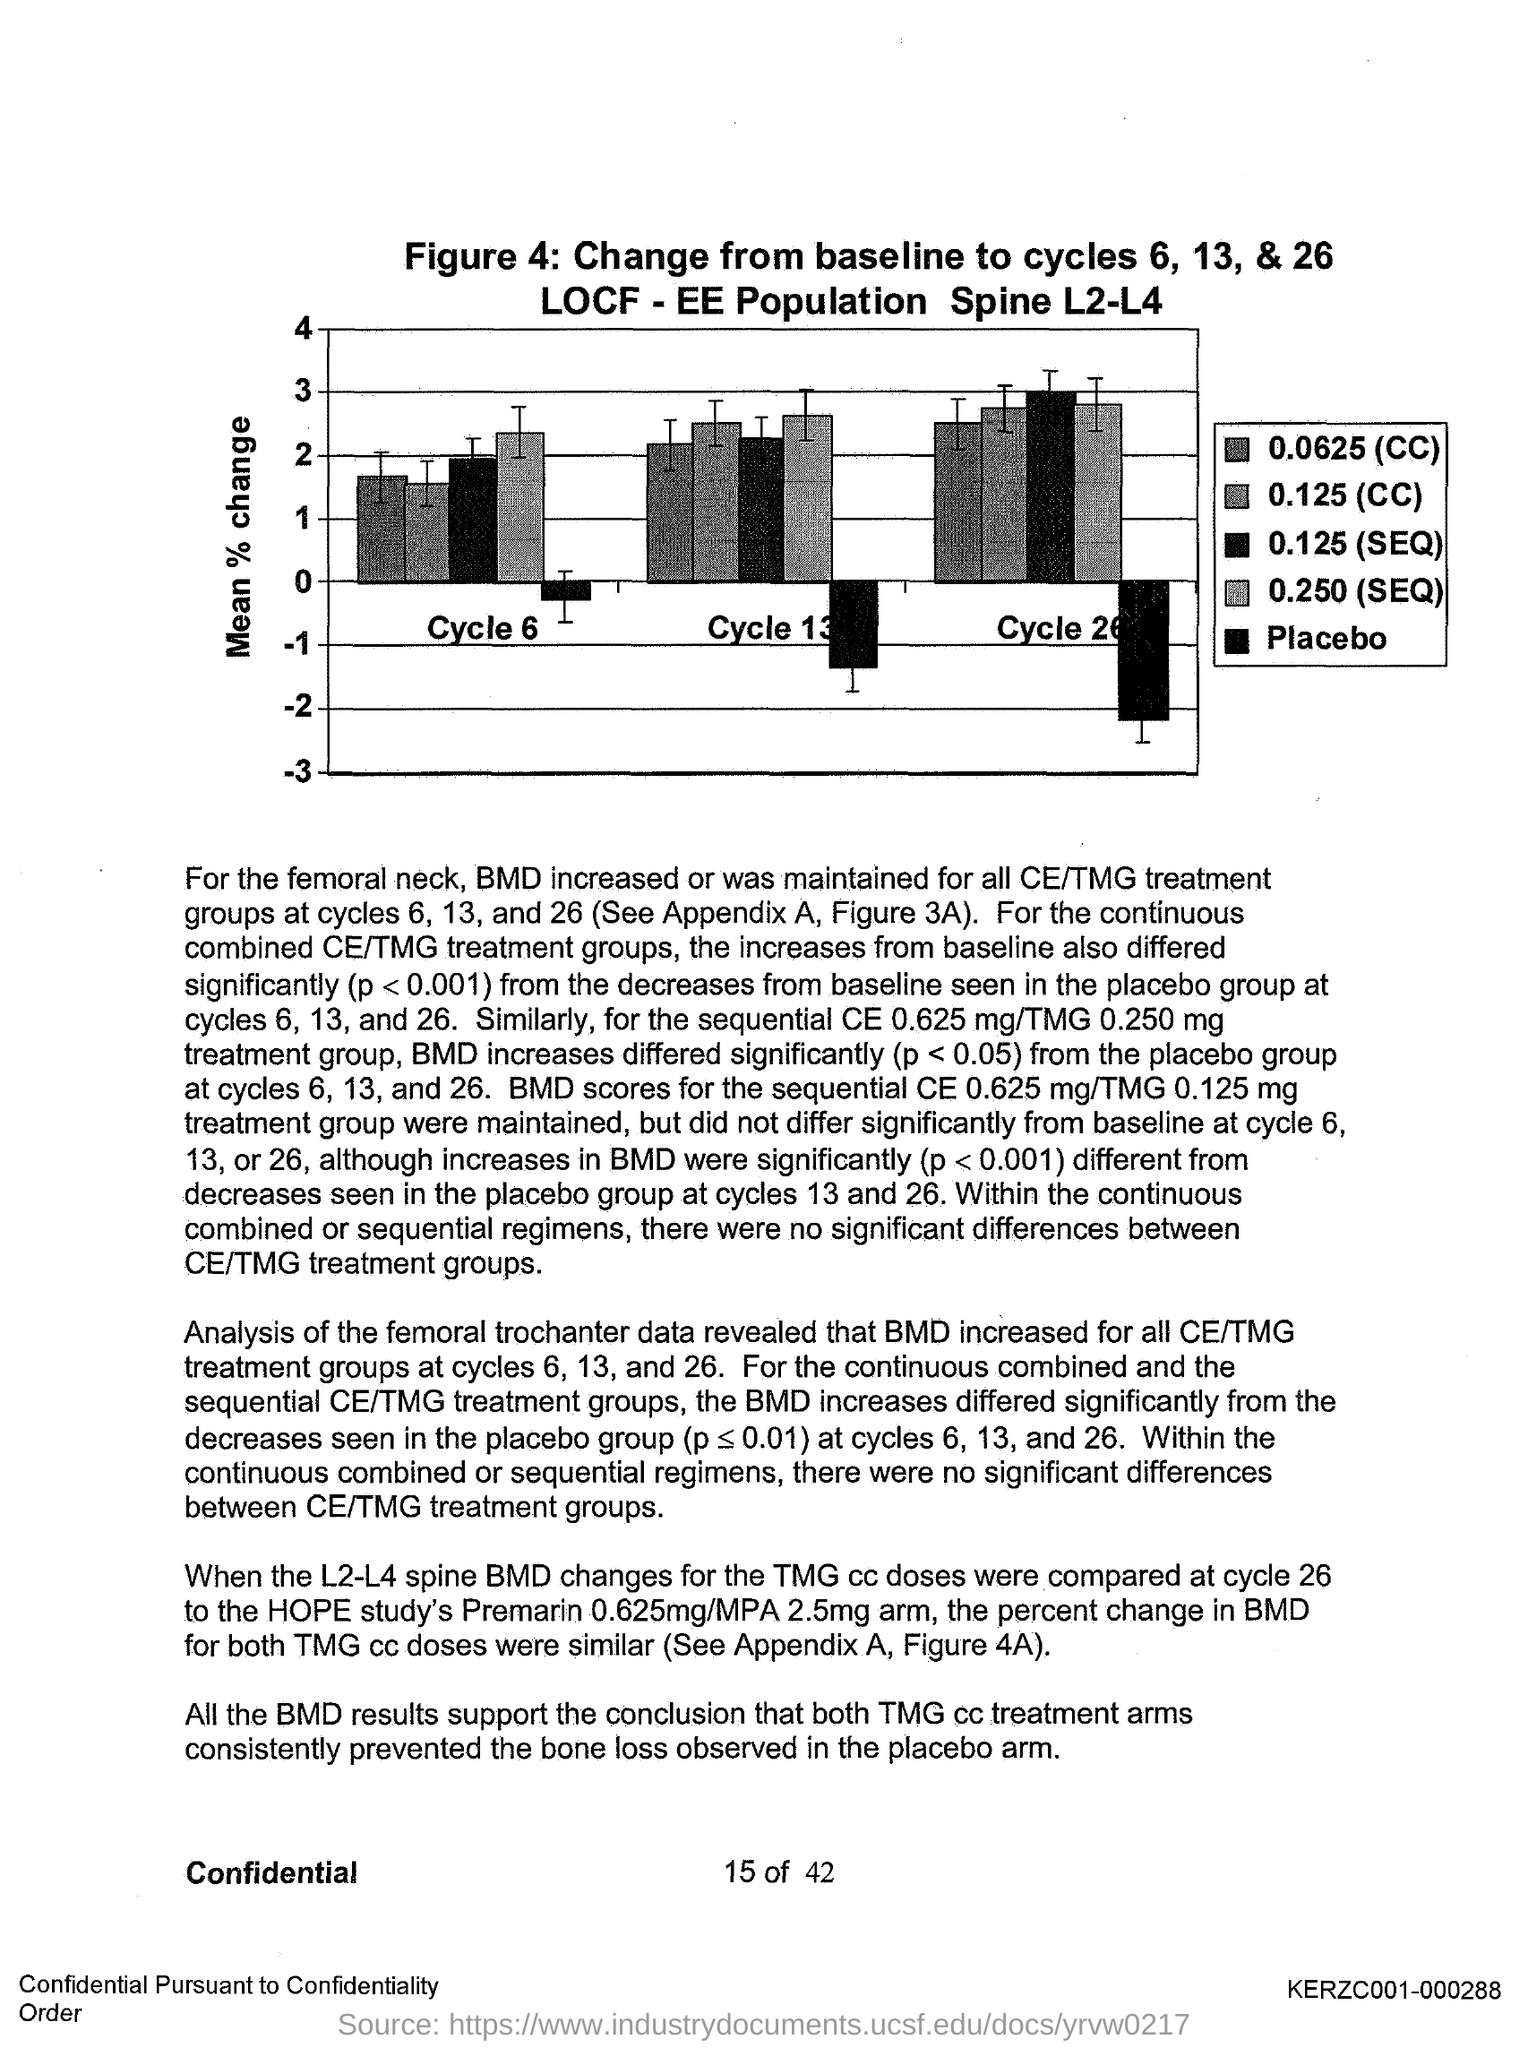Indicate a few pertinent items in this graphic. The page number is 15 out of 42. The "Y-axis" is a measure of the change in a particular value or variable over time. In the context of a graph or chart, the Y-axis represents the change or difference in the data being displayed, typically on a scale of positive or negative values. One common type of Y-axis measurement is the "mean % change," which represents the average change in a particular value or variable over a specific period of time. 